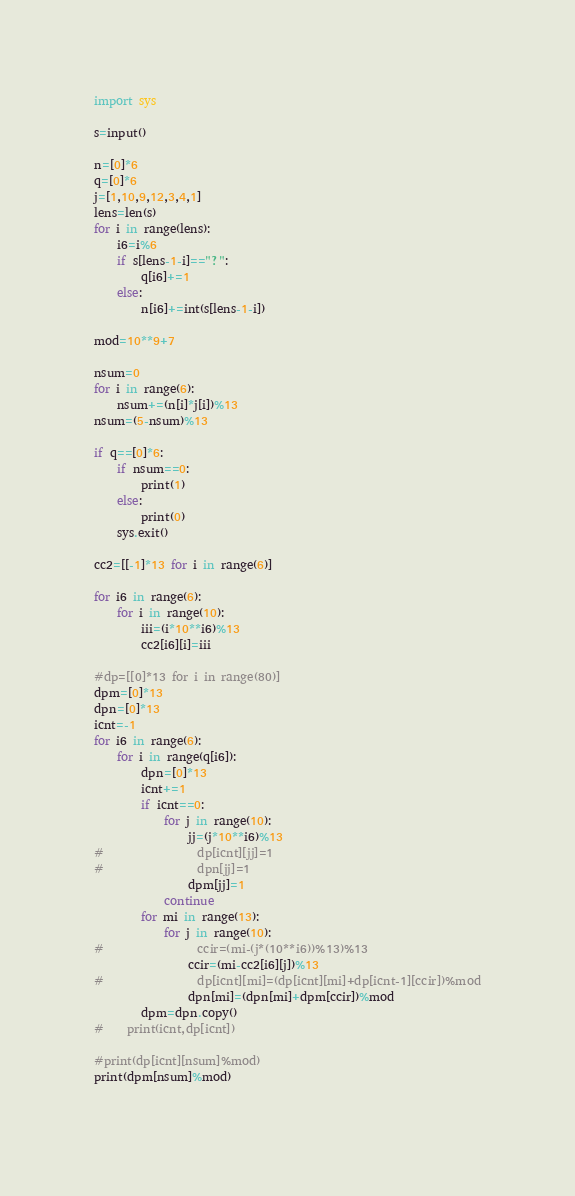<code> <loc_0><loc_0><loc_500><loc_500><_Python_>
import sys

s=input()

n=[0]*6
q=[0]*6
j=[1,10,9,12,3,4,1]
lens=len(s)
for i in range(lens):
    i6=i%6
    if s[lens-1-i]=="?":
        q[i6]+=1
    else:
        n[i6]+=int(s[lens-1-i])

mod=10**9+7
    
nsum=0
for i in range(6):
    nsum+=(n[i]*j[i])%13
nsum=(5-nsum)%13

if q==[0]*6:
    if nsum==0:
        print(1)
    else:
        print(0)
    sys.exit()
        
cc2=[[-1]*13 for i in range(6)]

for i6 in range(6):
    for i in range(10):
        iii=(i*10**i6)%13
        cc2[i6][i]=iii

#dp=[[0]*13 for i in range(80)]
dpm=[0]*13
dpn=[0]*13
icnt=-1
for i6 in range(6):
    for i in range(q[i6]):
        dpn=[0]*13
        icnt+=1
        if icnt==0:
            for j in range(10):
                jj=(j*10**i6)%13
#                dp[icnt][jj]=1            
#                dpn[jj]=1
                dpm[jj]=1
            continue
        for mi in range(13):
            for j in range(10):
#                ccir=(mi-(j*(10**i6))%13)%13
                ccir=(mi-cc2[i6][j])%13
#                dp[icnt][mi]=(dp[icnt][mi]+dp[icnt-1][ccir])%mod
                dpn[mi]=(dpn[mi]+dpm[ccir])%mod
        dpm=dpn.copy()  
#    print(icnt,dp[icnt])

#print(dp[icnt][nsum]%mod)
print(dpm[nsum]%mod)
            
</code> 